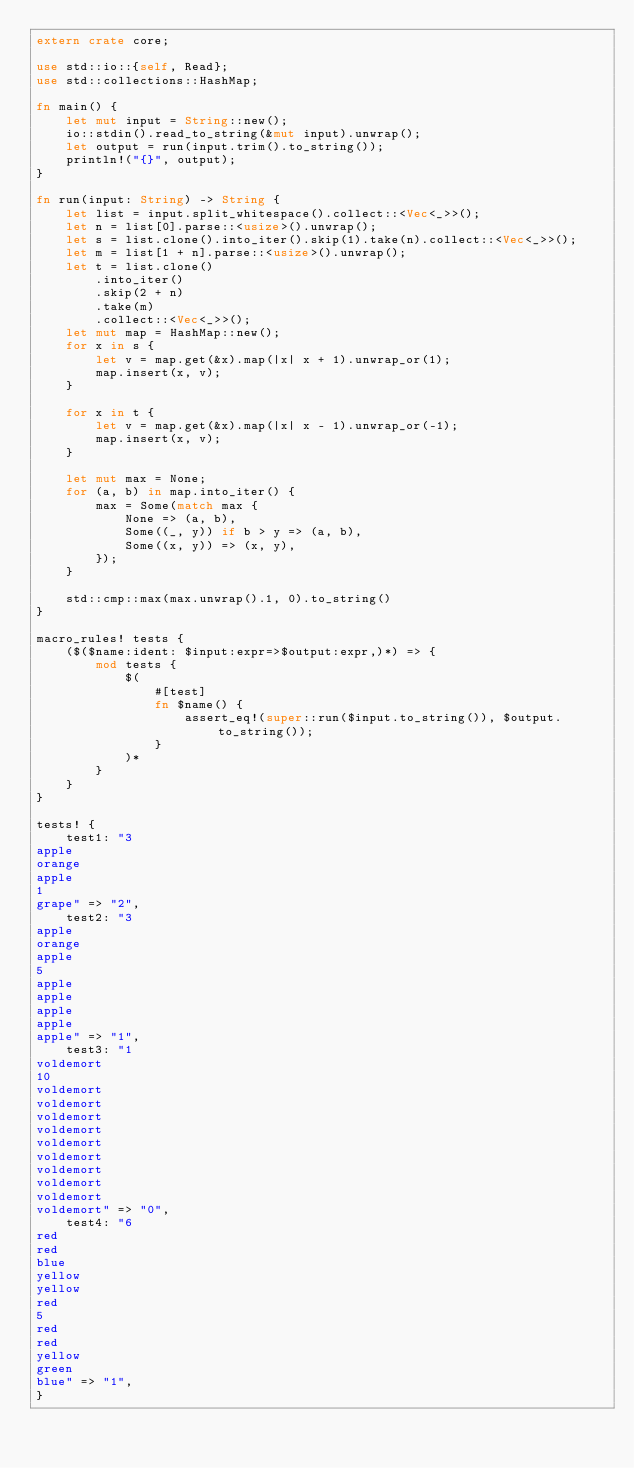Convert code to text. <code><loc_0><loc_0><loc_500><loc_500><_Rust_>extern crate core;

use std::io::{self, Read};
use std::collections::HashMap;

fn main() {
    let mut input = String::new();
    io::stdin().read_to_string(&mut input).unwrap();
    let output = run(input.trim().to_string());
    println!("{}", output);
}

fn run(input: String) -> String {
    let list = input.split_whitespace().collect::<Vec<_>>();
    let n = list[0].parse::<usize>().unwrap();
    let s = list.clone().into_iter().skip(1).take(n).collect::<Vec<_>>();
    let m = list[1 + n].parse::<usize>().unwrap();
    let t = list.clone()
        .into_iter()
        .skip(2 + n)
        .take(m)
        .collect::<Vec<_>>();
    let mut map = HashMap::new();
    for x in s {
        let v = map.get(&x).map(|x| x + 1).unwrap_or(1);
        map.insert(x, v);
    }

    for x in t {
        let v = map.get(&x).map(|x| x - 1).unwrap_or(-1);
        map.insert(x, v);
    }

    let mut max = None;
    for (a, b) in map.into_iter() {
        max = Some(match max {
            None => (a, b),
            Some((_, y)) if b > y => (a, b),
            Some((x, y)) => (x, y),
        });
    }

    std::cmp::max(max.unwrap().1, 0).to_string()
}

macro_rules! tests {
    ($($name:ident: $input:expr=>$output:expr,)*) => {
        mod tests {
            $(
                #[test]
                fn $name() {
                    assert_eq!(super::run($input.to_string()), $output.to_string());
                }
            )*
        }
    }
}

tests! {
    test1: "3
apple
orange
apple
1
grape" => "2",
    test2: "3
apple
orange
apple
5
apple
apple
apple
apple
apple" => "1",
    test3: "1
voldemort
10
voldemort
voldemort
voldemort
voldemort
voldemort
voldemort
voldemort
voldemort
voldemort
voldemort" => "0",
    test4: "6
red
red
blue
yellow
yellow
red
5
red
red
yellow
green
blue" => "1",
}
</code> 